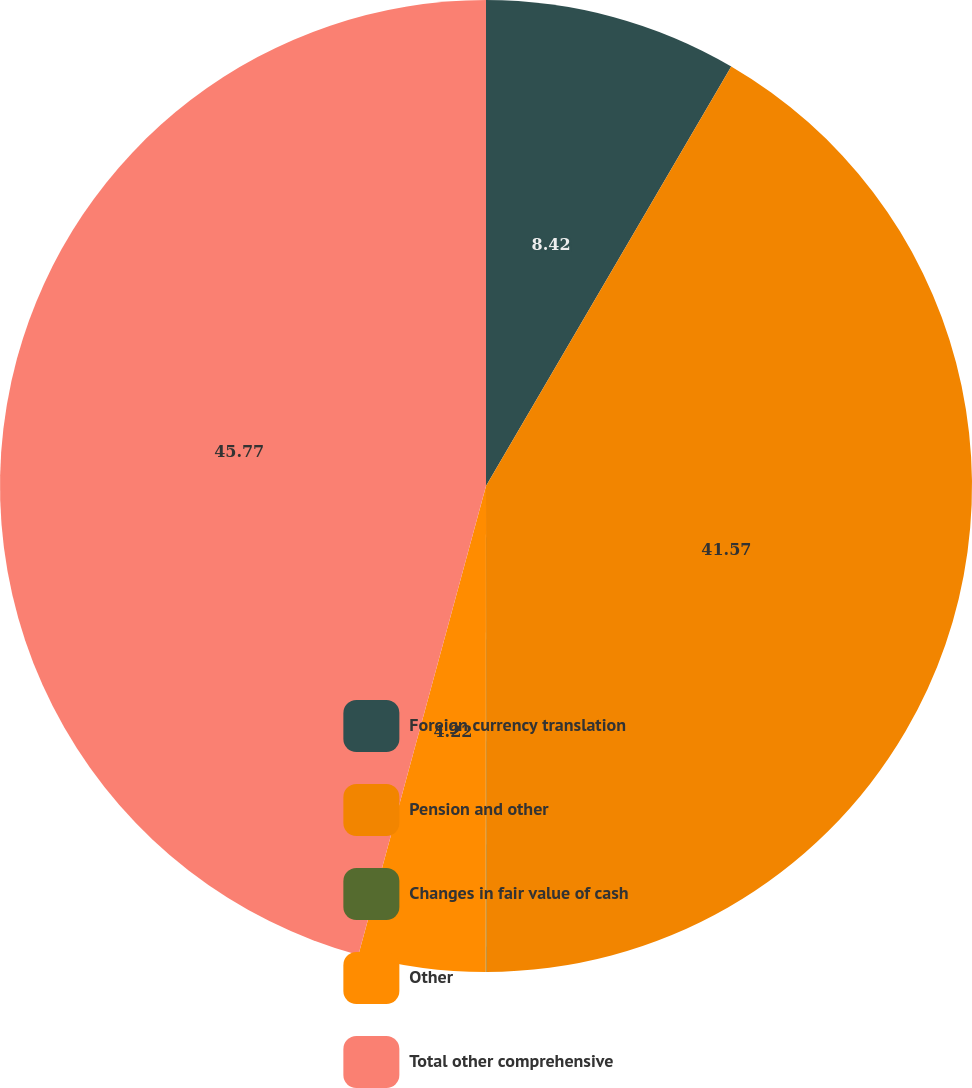Convert chart to OTSL. <chart><loc_0><loc_0><loc_500><loc_500><pie_chart><fcel>Foreign currency translation<fcel>Pension and other<fcel>Changes in fair value of cash<fcel>Other<fcel>Total other comprehensive<nl><fcel>8.42%<fcel>41.58%<fcel>0.02%<fcel>4.22%<fcel>45.78%<nl></chart> 